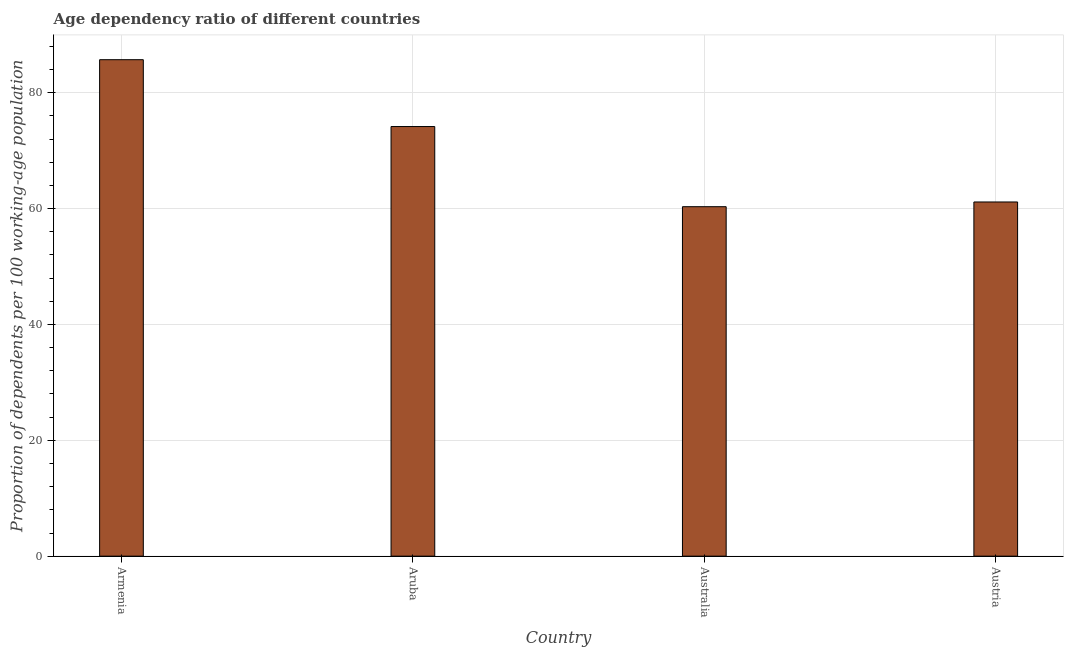What is the title of the graph?
Provide a short and direct response. Age dependency ratio of different countries. What is the label or title of the X-axis?
Offer a terse response. Country. What is the label or title of the Y-axis?
Provide a short and direct response. Proportion of dependents per 100 working-age population. What is the age dependency ratio in Aruba?
Give a very brief answer. 74.17. Across all countries, what is the maximum age dependency ratio?
Offer a very short reply. 85.71. Across all countries, what is the minimum age dependency ratio?
Give a very brief answer. 60.33. In which country was the age dependency ratio maximum?
Your answer should be very brief. Armenia. In which country was the age dependency ratio minimum?
Make the answer very short. Australia. What is the sum of the age dependency ratio?
Your response must be concise. 281.36. What is the difference between the age dependency ratio in Armenia and Australia?
Your response must be concise. 25.38. What is the average age dependency ratio per country?
Provide a succinct answer. 70.34. What is the median age dependency ratio?
Keep it short and to the point. 67.66. In how many countries, is the age dependency ratio greater than 4 ?
Make the answer very short. 4. What is the ratio of the age dependency ratio in Aruba to that in Australia?
Give a very brief answer. 1.23. Is the age dependency ratio in Aruba less than that in Australia?
Offer a very short reply. No. Is the difference between the age dependency ratio in Armenia and Austria greater than the difference between any two countries?
Provide a succinct answer. No. What is the difference between the highest and the second highest age dependency ratio?
Offer a terse response. 11.54. Is the sum of the age dependency ratio in Armenia and Austria greater than the maximum age dependency ratio across all countries?
Provide a succinct answer. Yes. What is the difference between the highest and the lowest age dependency ratio?
Ensure brevity in your answer.  25.38. How many bars are there?
Your answer should be very brief. 4. How many countries are there in the graph?
Your answer should be compact. 4. Are the values on the major ticks of Y-axis written in scientific E-notation?
Ensure brevity in your answer.  No. What is the Proportion of dependents per 100 working-age population in Armenia?
Make the answer very short. 85.71. What is the Proportion of dependents per 100 working-age population in Aruba?
Provide a short and direct response. 74.17. What is the Proportion of dependents per 100 working-age population in Australia?
Provide a short and direct response. 60.33. What is the Proportion of dependents per 100 working-age population in Austria?
Your answer should be very brief. 61.15. What is the difference between the Proportion of dependents per 100 working-age population in Armenia and Aruba?
Your answer should be compact. 11.54. What is the difference between the Proportion of dependents per 100 working-age population in Armenia and Australia?
Your answer should be compact. 25.38. What is the difference between the Proportion of dependents per 100 working-age population in Armenia and Austria?
Your answer should be very brief. 24.56. What is the difference between the Proportion of dependents per 100 working-age population in Aruba and Australia?
Offer a terse response. 13.84. What is the difference between the Proportion of dependents per 100 working-age population in Aruba and Austria?
Ensure brevity in your answer.  13.02. What is the difference between the Proportion of dependents per 100 working-age population in Australia and Austria?
Your answer should be very brief. -0.81. What is the ratio of the Proportion of dependents per 100 working-age population in Armenia to that in Aruba?
Your answer should be very brief. 1.16. What is the ratio of the Proportion of dependents per 100 working-age population in Armenia to that in Australia?
Your answer should be compact. 1.42. What is the ratio of the Proportion of dependents per 100 working-age population in Armenia to that in Austria?
Your answer should be very brief. 1.4. What is the ratio of the Proportion of dependents per 100 working-age population in Aruba to that in Australia?
Make the answer very short. 1.23. What is the ratio of the Proportion of dependents per 100 working-age population in Aruba to that in Austria?
Your answer should be compact. 1.21. 